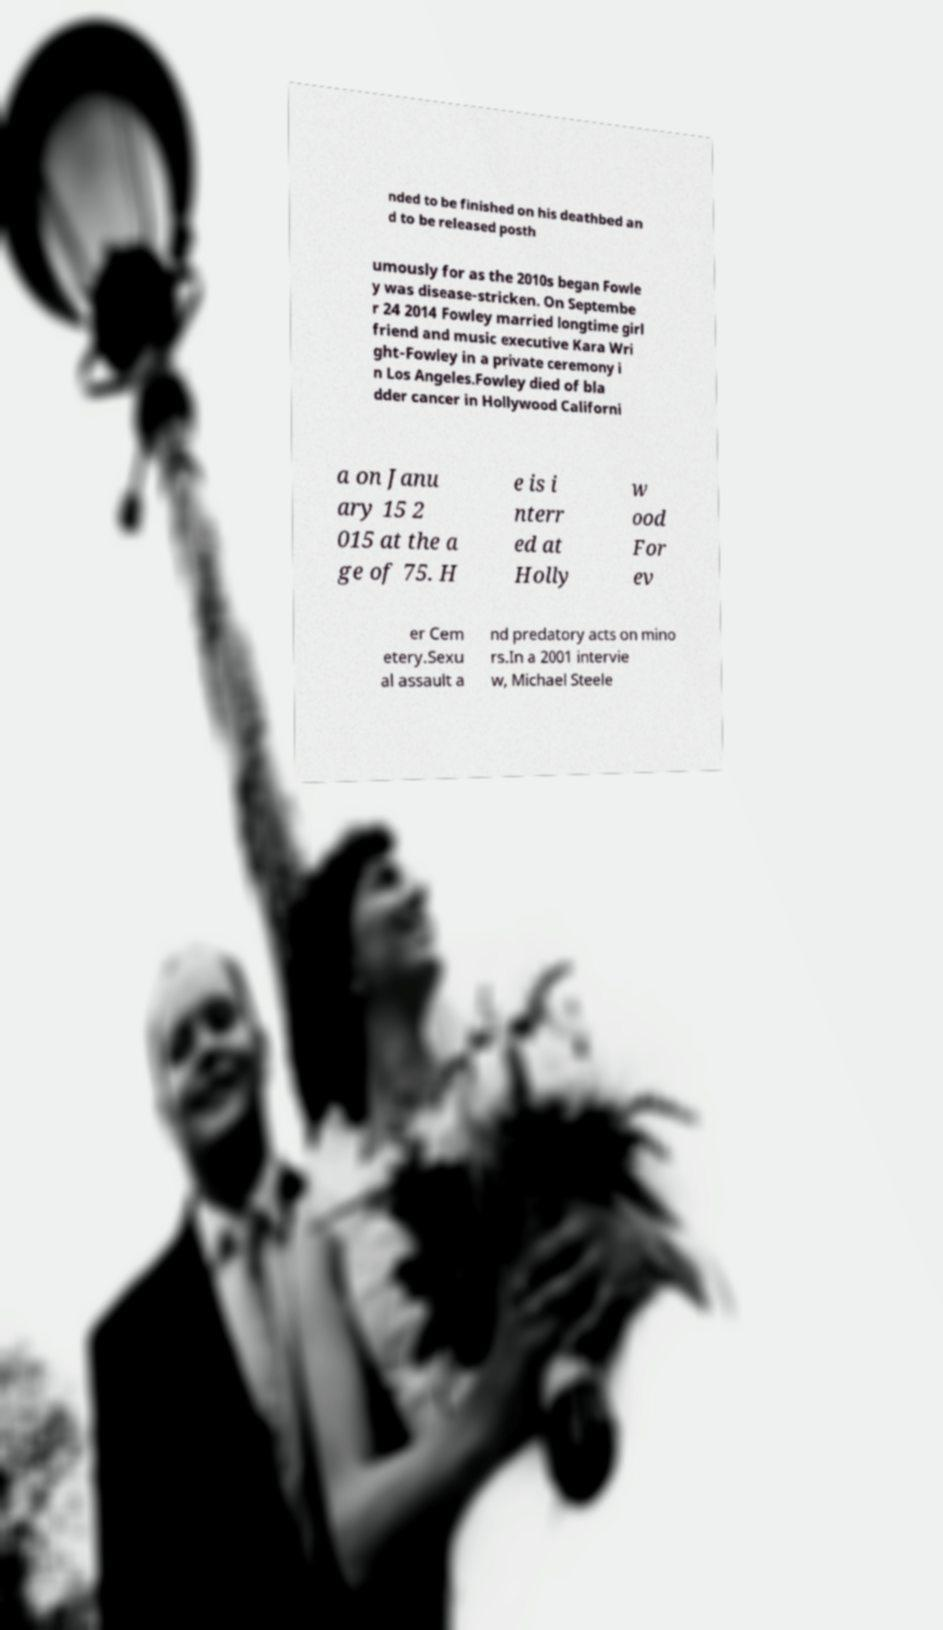Can you read and provide the text displayed in the image?This photo seems to have some interesting text. Can you extract and type it out for me? nded to be finished on his deathbed an d to be released posth umously for as the 2010s began Fowle y was disease-stricken. On Septembe r 24 2014 Fowley married longtime girl friend and music executive Kara Wri ght-Fowley in a private ceremony i n Los Angeles.Fowley died of bla dder cancer in Hollywood Californi a on Janu ary 15 2 015 at the a ge of 75. H e is i nterr ed at Holly w ood For ev er Cem etery.Sexu al assault a nd predatory acts on mino rs.In a 2001 intervie w, Michael Steele 